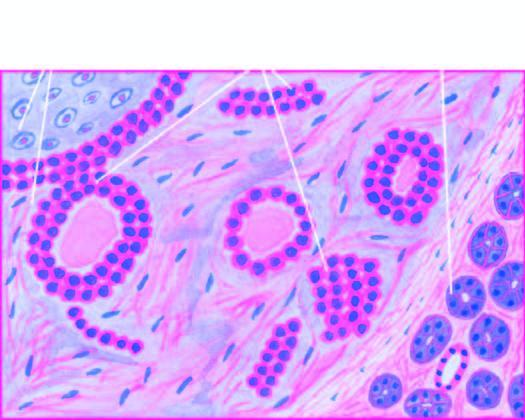what is comprised of ducts, acini, tubules, sheets and strands of cuboidal and myoepithelial cells?
Answer the question using a single word or phrase. Epithelial element 